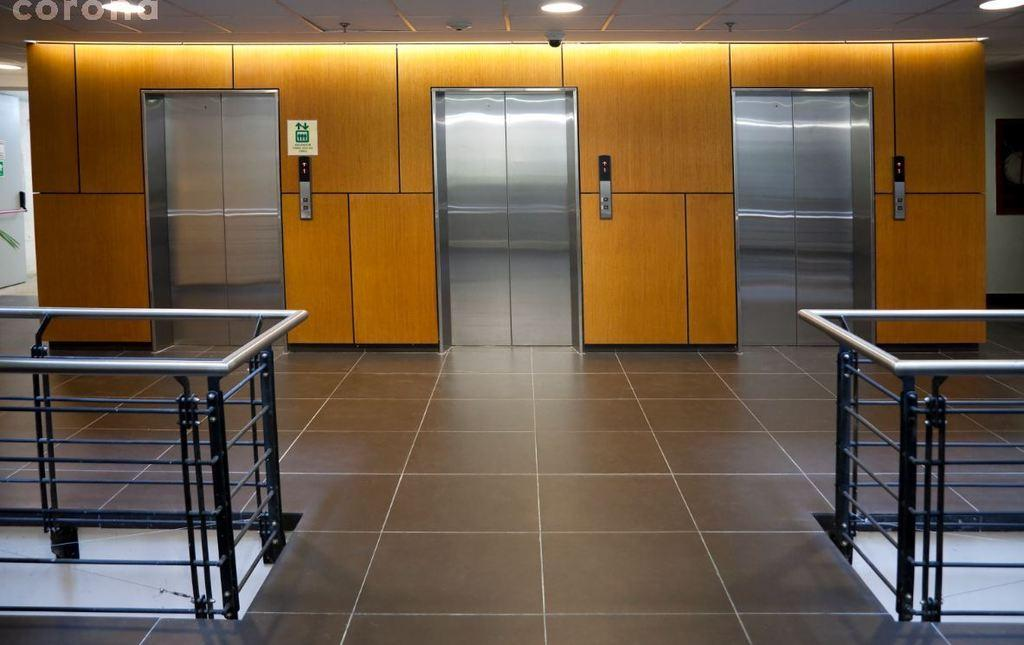What is visible on the ground in the image? The floor is visible in the image. What type of structures are present in the image? There are three lifts in the image. How many chairs are visible in the image? There are no chairs present in the image; it only features the floor and three lifts. What type of growth can be seen on the lifts in the image? There is no growth visible on the lifts in the image. Is there a rainstorm occurring in the image? There is no indication of a rainstorm in the image; it only features the floor and three lifts. 